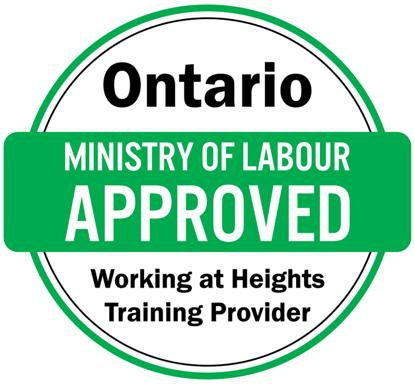What is the training mentioned in the text about the Ontario Ministry of Labour? The text mentions the 'Working at Heights Training Provider,' which is approved by the Ontario Ministry of Labour. This designation indicates that the training program adheres to stringent safety standards mandated by the government, ensuring that participants are well-prepared to safely perform tasks at various heights. 